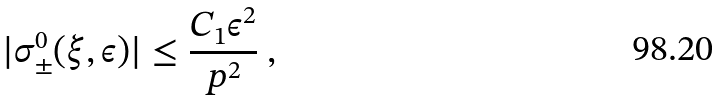<formula> <loc_0><loc_0><loc_500><loc_500>| \sigma ^ { 0 } _ { \pm } ( \xi , \epsilon ) | \leq \frac { C _ { 1 } \epsilon ^ { 2 } } { p ^ { 2 } } \ ,</formula> 